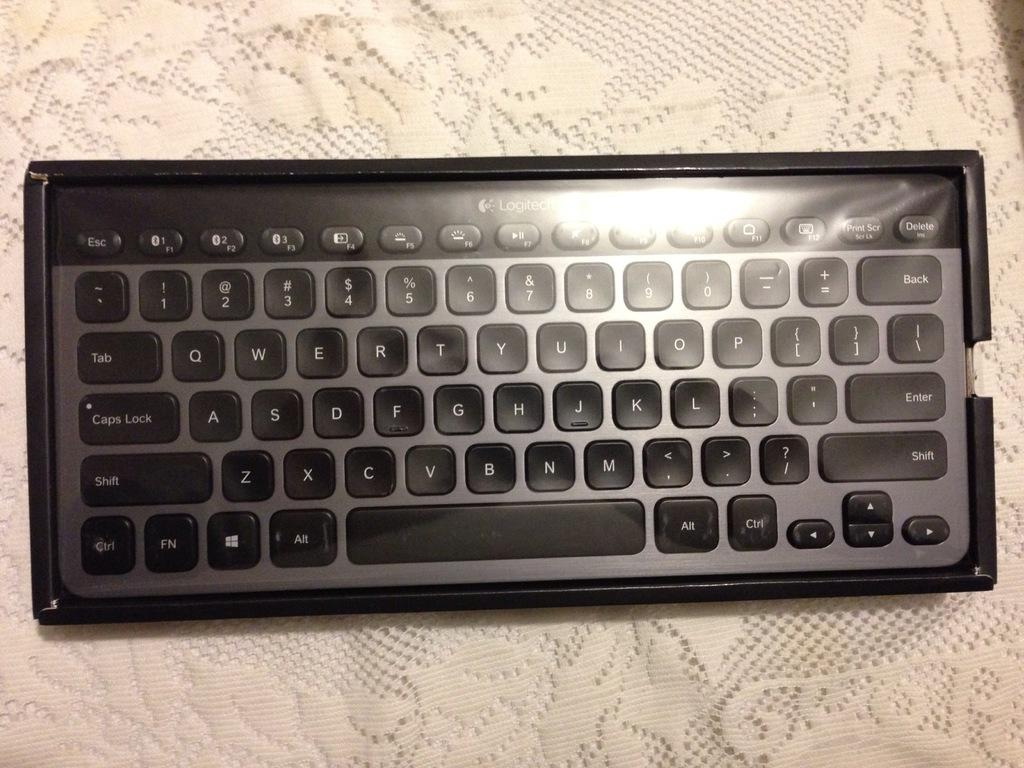Provide a one-sentence caption for the provided image. black and silver logitech keyboard on a knit tablecloth. 